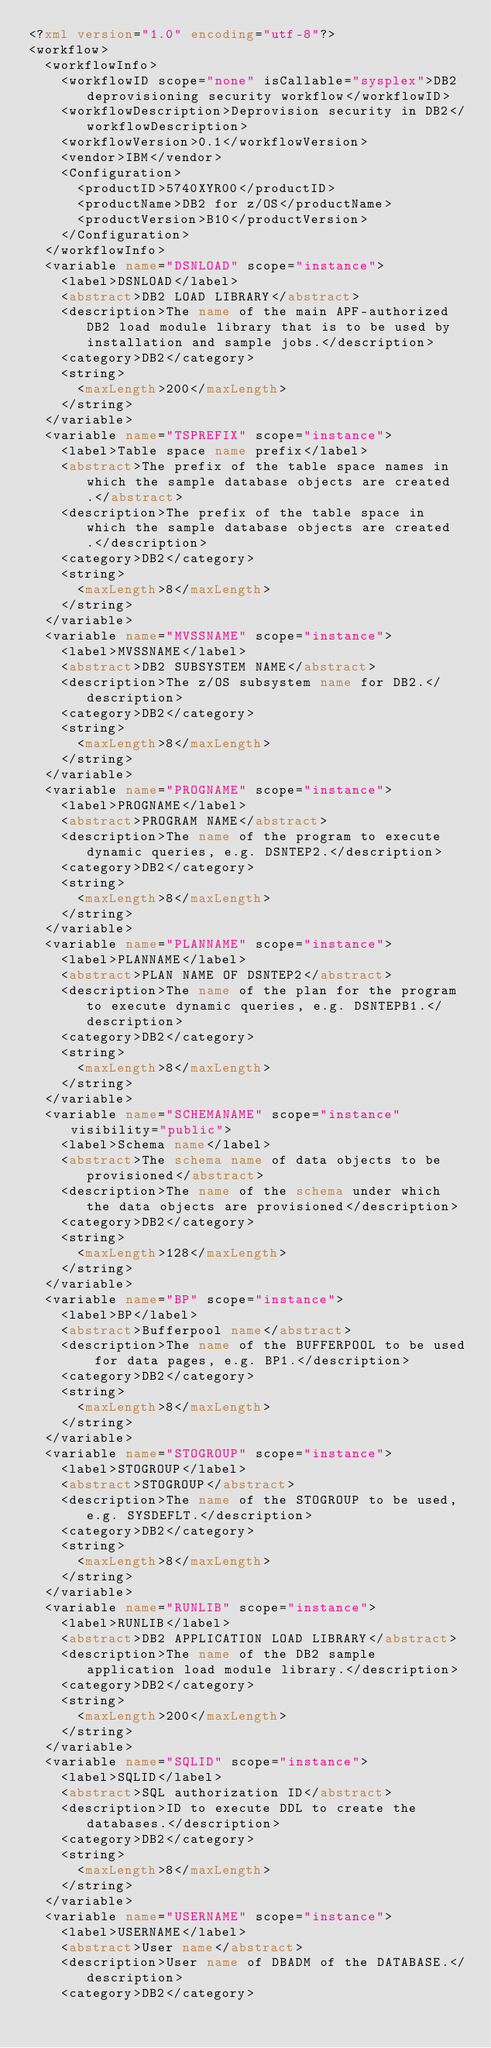<code> <loc_0><loc_0><loc_500><loc_500><_XML_><?xml version="1.0" encoding="utf-8"?>
<workflow>
  <workflowInfo>
    <workflowID scope="none" isCallable="sysplex">DB2 deprovisioning security workflow</workflowID>
    <workflowDescription>Deprovision security in DB2</workflowDescription>
    <workflowVersion>0.1</workflowVersion>
    <vendor>IBM</vendor>
    <Configuration>
      <productID>5740XYR00</productID>
      <productName>DB2 for z/OS</productName>
      <productVersion>B10</productVersion>
    </Configuration>
  </workflowInfo>
  <variable name="DSNLOAD" scope="instance">
    <label>DSNLOAD</label>
    <abstract>DB2 LOAD LIBRARY</abstract>
    <description>The name of the main APF-authorized DB2 load module library that is to be used by installation and sample jobs.</description>
    <category>DB2</category>
    <string>
      <maxLength>200</maxLength>
    </string>
  </variable>
  <variable name="TSPREFIX" scope="instance">
    <label>Table space name prefix</label>
    <abstract>The prefix of the table space names in which the sample database objects are created.</abstract>
    <description>The prefix of the table space in which the sample database objects are created.</description>
    <category>DB2</category>
    <string>
      <maxLength>8</maxLength>
    </string>
  </variable>
  <variable name="MVSSNAME" scope="instance">
    <label>MVSSNAME</label>
    <abstract>DB2 SUBSYSTEM NAME</abstract>
    <description>The z/OS subsystem name for DB2.</description>
    <category>DB2</category>
    <string>
      <maxLength>8</maxLength>
    </string>
  </variable>
  <variable name="PROGNAME" scope="instance">
    <label>PROGNAME</label>
    <abstract>PROGRAM NAME</abstract>
    <description>The name of the program to execute dynamic queries, e.g. DSNTEP2.</description>
    <category>DB2</category>
    <string>
      <maxLength>8</maxLength>
    </string>
  </variable>
  <variable name="PLANNAME" scope="instance">
    <label>PLANNAME</label>
    <abstract>PLAN NAME OF DSNTEP2</abstract>
    <description>The name of the plan for the program to execute dynamic queries, e.g. DSNTEPB1.</description>
    <category>DB2</category>
    <string>
      <maxLength>8</maxLength>
    </string>
  </variable>
  <variable name="SCHEMANAME" scope="instance" visibility="public">
    <label>Schema name</label>
    <abstract>The schema name of data objects to be provisioned</abstract>
    <description>The name of the schema under which the data objects are provisioned</description>
    <category>DB2</category>
    <string>
      <maxLength>128</maxLength>
    </string>
  </variable>
  <variable name="BP" scope="instance">
    <label>BP</label>
    <abstract>Bufferpool name</abstract>
    <description>The name of the BUFFERPOOL to be used for data pages, e.g. BP1.</description>
    <category>DB2</category>
    <string>
      <maxLength>8</maxLength>
    </string>
  </variable>
  <variable name="STOGROUP" scope="instance">
    <label>STOGROUP</label>
    <abstract>STOGROUP</abstract>
    <description>The name of the STOGROUP to be used, e.g. SYSDEFLT.</description>
    <category>DB2</category>
    <string>
      <maxLength>8</maxLength>
    </string>
  </variable>
  <variable name="RUNLIB" scope="instance">
    <label>RUNLIB</label>
    <abstract>DB2 APPLICATION LOAD LIBRARY</abstract>
    <description>The name of the DB2 sample application load module library.</description>
    <category>DB2</category>
    <string>
      <maxLength>200</maxLength>
    </string>
  </variable>
  <variable name="SQLID" scope="instance">
    <label>SQLID</label>
    <abstract>SQL authorization ID</abstract>
    <description>ID to execute DDL to create the databases.</description>
    <category>DB2</category>
    <string>
      <maxLength>8</maxLength>
    </string>
  </variable>
  <variable name="USERNAME" scope="instance">
    <label>USERNAME</label>
    <abstract>User name</abstract>
    <description>User name of DBADM of the DATABASE.</description>
    <category>DB2</category></code> 